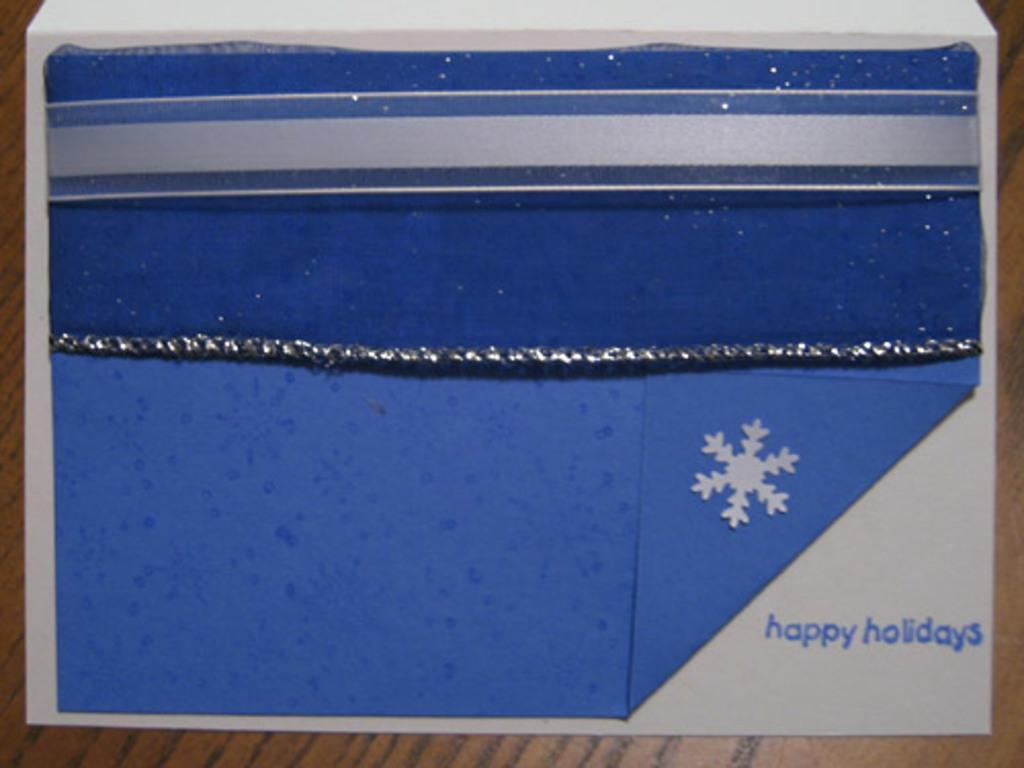<image>
Give a short and clear explanation of the subsequent image. A very simple card that says "happy holidays" in the lower right hand corner with a texture pocket where a gift card could be placed. 